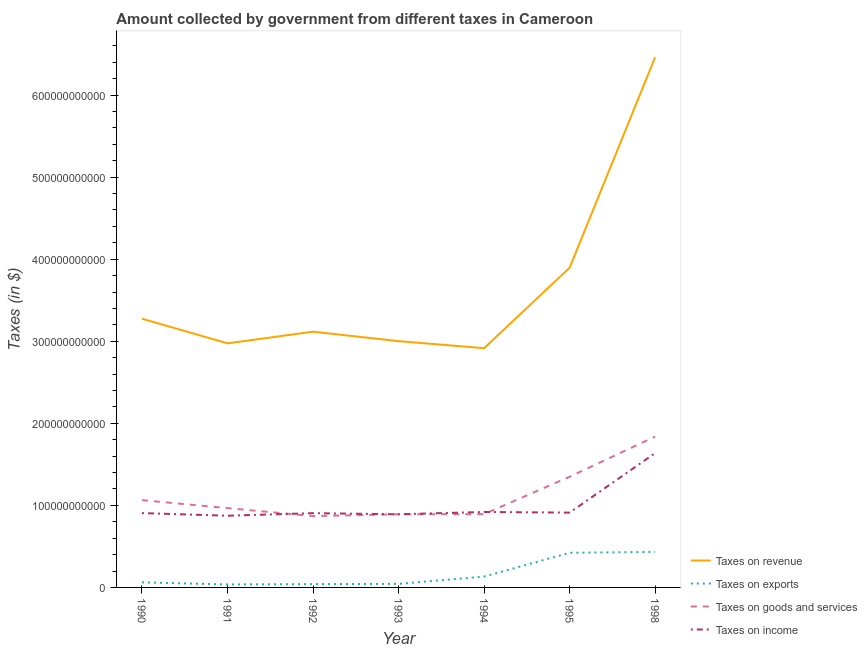How many different coloured lines are there?
Give a very brief answer. 4. Does the line corresponding to amount collected as tax on revenue intersect with the line corresponding to amount collected as tax on exports?
Keep it short and to the point. No. Is the number of lines equal to the number of legend labels?
Make the answer very short. Yes. What is the amount collected as tax on goods in 1990?
Give a very brief answer. 1.06e+11. Across all years, what is the maximum amount collected as tax on exports?
Your response must be concise. 4.33e+1. Across all years, what is the minimum amount collected as tax on revenue?
Keep it short and to the point. 2.92e+11. What is the total amount collected as tax on exports in the graph?
Make the answer very short. 1.17e+11. What is the difference between the amount collected as tax on revenue in 1991 and that in 1993?
Ensure brevity in your answer.  -2.68e+09. What is the difference between the amount collected as tax on revenue in 1993 and the amount collected as tax on exports in 1990?
Your response must be concise. 2.94e+11. What is the average amount collected as tax on revenue per year?
Give a very brief answer. 3.66e+11. In the year 1995, what is the difference between the amount collected as tax on exports and amount collected as tax on revenue?
Provide a short and direct response. -3.47e+11. In how many years, is the amount collected as tax on goods greater than 620000000000 $?
Your answer should be very brief. 0. What is the ratio of the amount collected as tax on income in 1993 to that in 1998?
Keep it short and to the point. 0.54. Is the amount collected as tax on exports in 1992 less than that in 1998?
Provide a succinct answer. Yes. What is the difference between the highest and the second highest amount collected as tax on goods?
Provide a short and direct response. 4.89e+1. What is the difference between the highest and the lowest amount collected as tax on goods?
Your response must be concise. 9.69e+1. In how many years, is the amount collected as tax on goods greater than the average amount collected as tax on goods taken over all years?
Your answer should be very brief. 2. How many lines are there?
Give a very brief answer. 4. What is the difference between two consecutive major ticks on the Y-axis?
Give a very brief answer. 1.00e+11. Are the values on the major ticks of Y-axis written in scientific E-notation?
Give a very brief answer. No. Does the graph contain any zero values?
Ensure brevity in your answer.  No. Where does the legend appear in the graph?
Provide a short and direct response. Bottom right. What is the title of the graph?
Your answer should be very brief. Amount collected by government from different taxes in Cameroon. What is the label or title of the X-axis?
Your answer should be compact. Year. What is the label or title of the Y-axis?
Make the answer very short. Taxes (in $). What is the Taxes (in $) of Taxes on revenue in 1990?
Give a very brief answer. 3.27e+11. What is the Taxes (in $) in Taxes on exports in 1990?
Ensure brevity in your answer.  6.18e+09. What is the Taxes (in $) in Taxes on goods and services in 1990?
Provide a succinct answer. 1.06e+11. What is the Taxes (in $) of Taxes on income in 1990?
Keep it short and to the point. 9.06e+1. What is the Taxes (in $) of Taxes on revenue in 1991?
Your answer should be very brief. 2.97e+11. What is the Taxes (in $) of Taxes on exports in 1991?
Keep it short and to the point. 3.64e+09. What is the Taxes (in $) in Taxes on goods and services in 1991?
Provide a succinct answer. 9.67e+1. What is the Taxes (in $) of Taxes on income in 1991?
Your answer should be compact. 8.74e+1. What is the Taxes (in $) in Taxes on revenue in 1992?
Make the answer very short. 3.12e+11. What is the Taxes (in $) in Taxes on exports in 1992?
Provide a succinct answer. 4.03e+09. What is the Taxes (in $) in Taxes on goods and services in 1992?
Give a very brief answer. 8.69e+1. What is the Taxes (in $) in Taxes on income in 1992?
Offer a very short reply. 9.05e+1. What is the Taxes (in $) of Taxes on revenue in 1993?
Provide a short and direct response. 3.00e+11. What is the Taxes (in $) of Taxes on exports in 1993?
Make the answer very short. 4.35e+09. What is the Taxes (in $) in Taxes on goods and services in 1993?
Your answer should be very brief. 8.92e+1. What is the Taxes (in $) in Taxes on income in 1993?
Make the answer very short. 8.92e+1. What is the Taxes (in $) of Taxes on revenue in 1994?
Give a very brief answer. 2.92e+11. What is the Taxes (in $) in Taxes on exports in 1994?
Keep it short and to the point. 1.32e+1. What is the Taxes (in $) in Taxes on goods and services in 1994?
Offer a very short reply. 8.93e+1. What is the Taxes (in $) in Taxes on income in 1994?
Give a very brief answer. 9.19e+1. What is the Taxes (in $) of Taxes on revenue in 1995?
Your answer should be compact. 3.90e+11. What is the Taxes (in $) of Taxes on exports in 1995?
Ensure brevity in your answer.  4.22e+1. What is the Taxes (in $) of Taxes on goods and services in 1995?
Offer a terse response. 1.35e+11. What is the Taxes (in $) of Taxes on income in 1995?
Your response must be concise. 9.12e+1. What is the Taxes (in $) in Taxes on revenue in 1998?
Provide a succinct answer. 6.46e+11. What is the Taxes (in $) of Taxes on exports in 1998?
Give a very brief answer. 4.33e+1. What is the Taxes (in $) of Taxes on goods and services in 1998?
Your answer should be compact. 1.84e+11. What is the Taxes (in $) of Taxes on income in 1998?
Provide a short and direct response. 1.64e+11. Across all years, what is the maximum Taxes (in $) in Taxes on revenue?
Give a very brief answer. 6.46e+11. Across all years, what is the maximum Taxes (in $) in Taxes on exports?
Your response must be concise. 4.33e+1. Across all years, what is the maximum Taxes (in $) of Taxes on goods and services?
Offer a very short reply. 1.84e+11. Across all years, what is the maximum Taxes (in $) of Taxes on income?
Your response must be concise. 1.64e+11. Across all years, what is the minimum Taxes (in $) of Taxes on revenue?
Your response must be concise. 2.92e+11. Across all years, what is the minimum Taxes (in $) in Taxes on exports?
Offer a very short reply. 3.64e+09. Across all years, what is the minimum Taxes (in $) of Taxes on goods and services?
Make the answer very short. 8.69e+1. Across all years, what is the minimum Taxes (in $) of Taxes on income?
Offer a very short reply. 8.74e+1. What is the total Taxes (in $) of Taxes on revenue in the graph?
Make the answer very short. 2.56e+12. What is the total Taxes (in $) in Taxes on exports in the graph?
Your answer should be very brief. 1.17e+11. What is the total Taxes (in $) in Taxes on goods and services in the graph?
Make the answer very short. 7.87e+11. What is the total Taxes (in $) in Taxes on income in the graph?
Offer a very short reply. 7.04e+11. What is the difference between the Taxes (in $) in Taxes on revenue in 1990 and that in 1991?
Your response must be concise. 3.00e+1. What is the difference between the Taxes (in $) of Taxes on exports in 1990 and that in 1991?
Your answer should be compact. 2.54e+09. What is the difference between the Taxes (in $) of Taxes on goods and services in 1990 and that in 1991?
Ensure brevity in your answer.  9.71e+09. What is the difference between the Taxes (in $) in Taxes on income in 1990 and that in 1991?
Your answer should be very brief. 3.21e+09. What is the difference between the Taxes (in $) of Taxes on revenue in 1990 and that in 1992?
Provide a short and direct response. 1.58e+1. What is the difference between the Taxes (in $) in Taxes on exports in 1990 and that in 1992?
Make the answer very short. 2.15e+09. What is the difference between the Taxes (in $) of Taxes on goods and services in 1990 and that in 1992?
Offer a terse response. 1.94e+1. What is the difference between the Taxes (in $) of Taxes on income in 1990 and that in 1992?
Give a very brief answer. 9.00e+07. What is the difference between the Taxes (in $) in Taxes on revenue in 1990 and that in 1993?
Provide a short and direct response. 2.74e+1. What is the difference between the Taxes (in $) in Taxes on exports in 1990 and that in 1993?
Keep it short and to the point. 1.83e+09. What is the difference between the Taxes (in $) in Taxes on goods and services in 1990 and that in 1993?
Provide a short and direct response. 1.72e+1. What is the difference between the Taxes (in $) of Taxes on income in 1990 and that in 1993?
Provide a succinct answer. 1.44e+09. What is the difference between the Taxes (in $) in Taxes on revenue in 1990 and that in 1994?
Make the answer very short. 3.59e+1. What is the difference between the Taxes (in $) in Taxes on exports in 1990 and that in 1994?
Provide a short and direct response. -7.05e+09. What is the difference between the Taxes (in $) in Taxes on goods and services in 1990 and that in 1994?
Keep it short and to the point. 1.71e+1. What is the difference between the Taxes (in $) of Taxes on income in 1990 and that in 1994?
Your response must be concise. -1.35e+09. What is the difference between the Taxes (in $) in Taxes on revenue in 1990 and that in 1995?
Ensure brevity in your answer.  -6.21e+1. What is the difference between the Taxes (in $) in Taxes on exports in 1990 and that in 1995?
Provide a succinct answer. -3.60e+1. What is the difference between the Taxes (in $) of Taxes on goods and services in 1990 and that in 1995?
Your answer should be compact. -2.85e+1. What is the difference between the Taxes (in $) in Taxes on income in 1990 and that in 1995?
Your answer should be compact. -5.60e+08. What is the difference between the Taxes (in $) in Taxes on revenue in 1990 and that in 1998?
Make the answer very short. -3.19e+11. What is the difference between the Taxes (in $) of Taxes on exports in 1990 and that in 1998?
Your answer should be very brief. -3.71e+1. What is the difference between the Taxes (in $) of Taxes on goods and services in 1990 and that in 1998?
Offer a very short reply. -7.74e+1. What is the difference between the Taxes (in $) in Taxes on income in 1990 and that in 1998?
Your answer should be very brief. -7.31e+1. What is the difference between the Taxes (in $) in Taxes on revenue in 1991 and that in 1992?
Your answer should be compact. -1.42e+1. What is the difference between the Taxes (in $) of Taxes on exports in 1991 and that in 1992?
Your answer should be compact. -3.90e+08. What is the difference between the Taxes (in $) of Taxes on goods and services in 1991 and that in 1992?
Your answer should be compact. 9.74e+09. What is the difference between the Taxes (in $) in Taxes on income in 1991 and that in 1992?
Offer a very short reply. -3.12e+09. What is the difference between the Taxes (in $) in Taxes on revenue in 1991 and that in 1993?
Give a very brief answer. -2.68e+09. What is the difference between the Taxes (in $) in Taxes on exports in 1991 and that in 1993?
Provide a succinct answer. -7.10e+08. What is the difference between the Taxes (in $) in Taxes on goods and services in 1991 and that in 1993?
Give a very brief answer. 7.50e+09. What is the difference between the Taxes (in $) of Taxes on income in 1991 and that in 1993?
Your answer should be very brief. -1.77e+09. What is the difference between the Taxes (in $) in Taxes on revenue in 1991 and that in 1994?
Offer a very short reply. 5.91e+09. What is the difference between the Taxes (in $) of Taxes on exports in 1991 and that in 1994?
Provide a short and direct response. -9.59e+09. What is the difference between the Taxes (in $) in Taxes on goods and services in 1991 and that in 1994?
Keep it short and to the point. 7.35e+09. What is the difference between the Taxes (in $) in Taxes on income in 1991 and that in 1994?
Ensure brevity in your answer.  -4.56e+09. What is the difference between the Taxes (in $) in Taxes on revenue in 1991 and that in 1995?
Your response must be concise. -9.21e+1. What is the difference between the Taxes (in $) in Taxes on exports in 1991 and that in 1995?
Your answer should be compact. -3.86e+1. What is the difference between the Taxes (in $) in Taxes on goods and services in 1991 and that in 1995?
Your answer should be very brief. -3.82e+1. What is the difference between the Taxes (in $) in Taxes on income in 1991 and that in 1995?
Keep it short and to the point. -3.77e+09. What is the difference between the Taxes (in $) of Taxes on revenue in 1991 and that in 1998?
Offer a very short reply. -3.49e+11. What is the difference between the Taxes (in $) in Taxes on exports in 1991 and that in 1998?
Offer a terse response. -3.97e+1. What is the difference between the Taxes (in $) of Taxes on goods and services in 1991 and that in 1998?
Provide a succinct answer. -8.72e+1. What is the difference between the Taxes (in $) in Taxes on income in 1991 and that in 1998?
Offer a terse response. -7.63e+1. What is the difference between the Taxes (in $) in Taxes on revenue in 1992 and that in 1993?
Provide a succinct answer. 1.15e+1. What is the difference between the Taxes (in $) of Taxes on exports in 1992 and that in 1993?
Give a very brief answer. -3.20e+08. What is the difference between the Taxes (in $) of Taxes on goods and services in 1992 and that in 1993?
Give a very brief answer. -2.24e+09. What is the difference between the Taxes (in $) in Taxes on income in 1992 and that in 1993?
Keep it short and to the point. 1.35e+09. What is the difference between the Taxes (in $) of Taxes on revenue in 1992 and that in 1994?
Your answer should be very brief. 2.01e+1. What is the difference between the Taxes (in $) in Taxes on exports in 1992 and that in 1994?
Offer a terse response. -9.20e+09. What is the difference between the Taxes (in $) of Taxes on goods and services in 1992 and that in 1994?
Make the answer very short. -2.39e+09. What is the difference between the Taxes (in $) of Taxes on income in 1992 and that in 1994?
Provide a short and direct response. -1.44e+09. What is the difference between the Taxes (in $) of Taxes on revenue in 1992 and that in 1995?
Your answer should be compact. -7.79e+1. What is the difference between the Taxes (in $) in Taxes on exports in 1992 and that in 1995?
Your answer should be very brief. -3.82e+1. What is the difference between the Taxes (in $) of Taxes on goods and services in 1992 and that in 1995?
Keep it short and to the point. -4.80e+1. What is the difference between the Taxes (in $) of Taxes on income in 1992 and that in 1995?
Provide a short and direct response. -6.50e+08. What is the difference between the Taxes (in $) of Taxes on revenue in 1992 and that in 1998?
Provide a succinct answer. -3.35e+11. What is the difference between the Taxes (in $) of Taxes on exports in 1992 and that in 1998?
Keep it short and to the point. -3.93e+1. What is the difference between the Taxes (in $) in Taxes on goods and services in 1992 and that in 1998?
Your answer should be compact. -9.69e+1. What is the difference between the Taxes (in $) of Taxes on income in 1992 and that in 1998?
Keep it short and to the point. -7.32e+1. What is the difference between the Taxes (in $) of Taxes on revenue in 1993 and that in 1994?
Your answer should be very brief. 8.59e+09. What is the difference between the Taxes (in $) of Taxes on exports in 1993 and that in 1994?
Offer a very short reply. -8.88e+09. What is the difference between the Taxes (in $) in Taxes on goods and services in 1993 and that in 1994?
Provide a short and direct response. -1.50e+08. What is the difference between the Taxes (in $) of Taxes on income in 1993 and that in 1994?
Make the answer very short. -2.79e+09. What is the difference between the Taxes (in $) of Taxes on revenue in 1993 and that in 1995?
Provide a succinct answer. -8.94e+1. What is the difference between the Taxes (in $) in Taxes on exports in 1993 and that in 1995?
Your answer should be compact. -3.79e+1. What is the difference between the Taxes (in $) in Taxes on goods and services in 1993 and that in 1995?
Provide a short and direct response. -4.57e+1. What is the difference between the Taxes (in $) in Taxes on income in 1993 and that in 1995?
Offer a terse response. -2.00e+09. What is the difference between the Taxes (in $) in Taxes on revenue in 1993 and that in 1998?
Give a very brief answer. -3.46e+11. What is the difference between the Taxes (in $) of Taxes on exports in 1993 and that in 1998?
Offer a very short reply. -3.90e+1. What is the difference between the Taxes (in $) of Taxes on goods and services in 1993 and that in 1998?
Give a very brief answer. -9.47e+1. What is the difference between the Taxes (in $) of Taxes on income in 1993 and that in 1998?
Provide a succinct answer. -7.45e+1. What is the difference between the Taxes (in $) in Taxes on revenue in 1994 and that in 1995?
Give a very brief answer. -9.80e+1. What is the difference between the Taxes (in $) in Taxes on exports in 1994 and that in 1995?
Your answer should be compact. -2.90e+1. What is the difference between the Taxes (in $) of Taxes on goods and services in 1994 and that in 1995?
Your answer should be very brief. -4.56e+1. What is the difference between the Taxes (in $) of Taxes on income in 1994 and that in 1995?
Offer a terse response. 7.90e+08. What is the difference between the Taxes (in $) in Taxes on revenue in 1994 and that in 1998?
Offer a very short reply. -3.55e+11. What is the difference between the Taxes (in $) in Taxes on exports in 1994 and that in 1998?
Provide a short and direct response. -3.01e+1. What is the difference between the Taxes (in $) in Taxes on goods and services in 1994 and that in 1998?
Provide a short and direct response. -9.45e+1. What is the difference between the Taxes (in $) of Taxes on income in 1994 and that in 1998?
Keep it short and to the point. -7.18e+1. What is the difference between the Taxes (in $) in Taxes on revenue in 1995 and that in 1998?
Your response must be concise. -2.57e+11. What is the difference between the Taxes (in $) in Taxes on exports in 1995 and that in 1998?
Offer a very short reply. -1.11e+09. What is the difference between the Taxes (in $) in Taxes on goods and services in 1995 and that in 1998?
Offer a very short reply. -4.89e+1. What is the difference between the Taxes (in $) of Taxes on income in 1995 and that in 1998?
Your response must be concise. -7.25e+1. What is the difference between the Taxes (in $) of Taxes on revenue in 1990 and the Taxes (in $) of Taxes on exports in 1991?
Ensure brevity in your answer.  3.24e+11. What is the difference between the Taxes (in $) in Taxes on revenue in 1990 and the Taxes (in $) in Taxes on goods and services in 1991?
Keep it short and to the point. 2.31e+11. What is the difference between the Taxes (in $) in Taxes on revenue in 1990 and the Taxes (in $) in Taxes on income in 1991?
Offer a terse response. 2.40e+11. What is the difference between the Taxes (in $) in Taxes on exports in 1990 and the Taxes (in $) in Taxes on goods and services in 1991?
Keep it short and to the point. -9.05e+1. What is the difference between the Taxes (in $) of Taxes on exports in 1990 and the Taxes (in $) of Taxes on income in 1991?
Your answer should be compact. -8.12e+1. What is the difference between the Taxes (in $) in Taxes on goods and services in 1990 and the Taxes (in $) in Taxes on income in 1991?
Make the answer very short. 1.90e+1. What is the difference between the Taxes (in $) of Taxes on revenue in 1990 and the Taxes (in $) of Taxes on exports in 1992?
Offer a terse response. 3.23e+11. What is the difference between the Taxes (in $) of Taxes on revenue in 1990 and the Taxes (in $) of Taxes on goods and services in 1992?
Offer a terse response. 2.41e+11. What is the difference between the Taxes (in $) of Taxes on revenue in 1990 and the Taxes (in $) of Taxes on income in 1992?
Provide a succinct answer. 2.37e+11. What is the difference between the Taxes (in $) of Taxes on exports in 1990 and the Taxes (in $) of Taxes on goods and services in 1992?
Provide a succinct answer. -8.07e+1. What is the difference between the Taxes (in $) in Taxes on exports in 1990 and the Taxes (in $) in Taxes on income in 1992?
Offer a very short reply. -8.43e+1. What is the difference between the Taxes (in $) in Taxes on goods and services in 1990 and the Taxes (in $) in Taxes on income in 1992?
Your response must be concise. 1.59e+1. What is the difference between the Taxes (in $) of Taxes on revenue in 1990 and the Taxes (in $) of Taxes on exports in 1993?
Your answer should be compact. 3.23e+11. What is the difference between the Taxes (in $) in Taxes on revenue in 1990 and the Taxes (in $) in Taxes on goods and services in 1993?
Provide a succinct answer. 2.38e+11. What is the difference between the Taxes (in $) in Taxes on revenue in 1990 and the Taxes (in $) in Taxes on income in 1993?
Ensure brevity in your answer.  2.38e+11. What is the difference between the Taxes (in $) in Taxes on exports in 1990 and the Taxes (in $) in Taxes on goods and services in 1993?
Ensure brevity in your answer.  -8.30e+1. What is the difference between the Taxes (in $) of Taxes on exports in 1990 and the Taxes (in $) of Taxes on income in 1993?
Offer a terse response. -8.30e+1. What is the difference between the Taxes (in $) of Taxes on goods and services in 1990 and the Taxes (in $) of Taxes on income in 1993?
Your answer should be compact. 1.72e+1. What is the difference between the Taxes (in $) of Taxes on revenue in 1990 and the Taxes (in $) of Taxes on exports in 1994?
Provide a succinct answer. 3.14e+11. What is the difference between the Taxes (in $) in Taxes on revenue in 1990 and the Taxes (in $) in Taxes on goods and services in 1994?
Make the answer very short. 2.38e+11. What is the difference between the Taxes (in $) in Taxes on revenue in 1990 and the Taxes (in $) in Taxes on income in 1994?
Provide a short and direct response. 2.36e+11. What is the difference between the Taxes (in $) in Taxes on exports in 1990 and the Taxes (in $) in Taxes on goods and services in 1994?
Offer a terse response. -8.31e+1. What is the difference between the Taxes (in $) of Taxes on exports in 1990 and the Taxes (in $) of Taxes on income in 1994?
Provide a succinct answer. -8.58e+1. What is the difference between the Taxes (in $) in Taxes on goods and services in 1990 and the Taxes (in $) in Taxes on income in 1994?
Ensure brevity in your answer.  1.44e+1. What is the difference between the Taxes (in $) of Taxes on revenue in 1990 and the Taxes (in $) of Taxes on exports in 1995?
Keep it short and to the point. 2.85e+11. What is the difference between the Taxes (in $) in Taxes on revenue in 1990 and the Taxes (in $) in Taxes on goods and services in 1995?
Your answer should be compact. 1.93e+11. What is the difference between the Taxes (in $) in Taxes on revenue in 1990 and the Taxes (in $) in Taxes on income in 1995?
Your answer should be compact. 2.36e+11. What is the difference between the Taxes (in $) of Taxes on exports in 1990 and the Taxes (in $) of Taxes on goods and services in 1995?
Your response must be concise. -1.29e+11. What is the difference between the Taxes (in $) of Taxes on exports in 1990 and the Taxes (in $) of Taxes on income in 1995?
Offer a very short reply. -8.50e+1. What is the difference between the Taxes (in $) in Taxes on goods and services in 1990 and the Taxes (in $) in Taxes on income in 1995?
Your answer should be compact. 1.52e+1. What is the difference between the Taxes (in $) of Taxes on revenue in 1990 and the Taxes (in $) of Taxes on exports in 1998?
Ensure brevity in your answer.  2.84e+11. What is the difference between the Taxes (in $) in Taxes on revenue in 1990 and the Taxes (in $) in Taxes on goods and services in 1998?
Your answer should be compact. 1.44e+11. What is the difference between the Taxes (in $) of Taxes on revenue in 1990 and the Taxes (in $) of Taxes on income in 1998?
Provide a succinct answer. 1.64e+11. What is the difference between the Taxes (in $) of Taxes on exports in 1990 and the Taxes (in $) of Taxes on goods and services in 1998?
Your answer should be compact. -1.78e+11. What is the difference between the Taxes (in $) in Taxes on exports in 1990 and the Taxes (in $) in Taxes on income in 1998?
Offer a terse response. -1.58e+11. What is the difference between the Taxes (in $) of Taxes on goods and services in 1990 and the Taxes (in $) of Taxes on income in 1998?
Ensure brevity in your answer.  -5.73e+1. What is the difference between the Taxes (in $) in Taxes on revenue in 1991 and the Taxes (in $) in Taxes on exports in 1992?
Provide a short and direct response. 2.93e+11. What is the difference between the Taxes (in $) in Taxes on revenue in 1991 and the Taxes (in $) in Taxes on goods and services in 1992?
Your response must be concise. 2.11e+11. What is the difference between the Taxes (in $) in Taxes on revenue in 1991 and the Taxes (in $) in Taxes on income in 1992?
Your response must be concise. 2.07e+11. What is the difference between the Taxes (in $) of Taxes on exports in 1991 and the Taxes (in $) of Taxes on goods and services in 1992?
Your answer should be compact. -8.33e+1. What is the difference between the Taxes (in $) of Taxes on exports in 1991 and the Taxes (in $) of Taxes on income in 1992?
Your answer should be very brief. -8.69e+1. What is the difference between the Taxes (in $) of Taxes on goods and services in 1991 and the Taxes (in $) of Taxes on income in 1992?
Your response must be concise. 6.16e+09. What is the difference between the Taxes (in $) in Taxes on revenue in 1991 and the Taxes (in $) in Taxes on exports in 1993?
Your answer should be very brief. 2.93e+11. What is the difference between the Taxes (in $) of Taxes on revenue in 1991 and the Taxes (in $) of Taxes on goods and services in 1993?
Offer a very short reply. 2.08e+11. What is the difference between the Taxes (in $) in Taxes on revenue in 1991 and the Taxes (in $) in Taxes on income in 1993?
Ensure brevity in your answer.  2.08e+11. What is the difference between the Taxes (in $) of Taxes on exports in 1991 and the Taxes (in $) of Taxes on goods and services in 1993?
Keep it short and to the point. -8.55e+1. What is the difference between the Taxes (in $) of Taxes on exports in 1991 and the Taxes (in $) of Taxes on income in 1993?
Your answer should be compact. -8.55e+1. What is the difference between the Taxes (in $) in Taxes on goods and services in 1991 and the Taxes (in $) in Taxes on income in 1993?
Keep it short and to the point. 7.51e+09. What is the difference between the Taxes (in $) of Taxes on revenue in 1991 and the Taxes (in $) of Taxes on exports in 1994?
Your answer should be compact. 2.84e+11. What is the difference between the Taxes (in $) in Taxes on revenue in 1991 and the Taxes (in $) in Taxes on goods and services in 1994?
Provide a succinct answer. 2.08e+11. What is the difference between the Taxes (in $) in Taxes on revenue in 1991 and the Taxes (in $) in Taxes on income in 1994?
Your answer should be very brief. 2.06e+11. What is the difference between the Taxes (in $) in Taxes on exports in 1991 and the Taxes (in $) in Taxes on goods and services in 1994?
Your answer should be very brief. -8.57e+1. What is the difference between the Taxes (in $) of Taxes on exports in 1991 and the Taxes (in $) of Taxes on income in 1994?
Provide a short and direct response. -8.83e+1. What is the difference between the Taxes (in $) in Taxes on goods and services in 1991 and the Taxes (in $) in Taxes on income in 1994?
Your answer should be very brief. 4.72e+09. What is the difference between the Taxes (in $) in Taxes on revenue in 1991 and the Taxes (in $) in Taxes on exports in 1995?
Keep it short and to the point. 2.55e+11. What is the difference between the Taxes (in $) of Taxes on revenue in 1991 and the Taxes (in $) of Taxes on goods and services in 1995?
Offer a terse response. 1.63e+11. What is the difference between the Taxes (in $) in Taxes on revenue in 1991 and the Taxes (in $) in Taxes on income in 1995?
Provide a succinct answer. 2.06e+11. What is the difference between the Taxes (in $) in Taxes on exports in 1991 and the Taxes (in $) in Taxes on goods and services in 1995?
Make the answer very short. -1.31e+11. What is the difference between the Taxes (in $) of Taxes on exports in 1991 and the Taxes (in $) of Taxes on income in 1995?
Keep it short and to the point. -8.75e+1. What is the difference between the Taxes (in $) in Taxes on goods and services in 1991 and the Taxes (in $) in Taxes on income in 1995?
Your answer should be compact. 5.51e+09. What is the difference between the Taxes (in $) of Taxes on revenue in 1991 and the Taxes (in $) of Taxes on exports in 1998?
Your answer should be compact. 2.54e+11. What is the difference between the Taxes (in $) in Taxes on revenue in 1991 and the Taxes (in $) in Taxes on goods and services in 1998?
Offer a terse response. 1.14e+11. What is the difference between the Taxes (in $) in Taxes on revenue in 1991 and the Taxes (in $) in Taxes on income in 1998?
Offer a terse response. 1.34e+11. What is the difference between the Taxes (in $) in Taxes on exports in 1991 and the Taxes (in $) in Taxes on goods and services in 1998?
Ensure brevity in your answer.  -1.80e+11. What is the difference between the Taxes (in $) of Taxes on exports in 1991 and the Taxes (in $) of Taxes on income in 1998?
Your response must be concise. -1.60e+11. What is the difference between the Taxes (in $) of Taxes on goods and services in 1991 and the Taxes (in $) of Taxes on income in 1998?
Your answer should be compact. -6.70e+1. What is the difference between the Taxes (in $) in Taxes on revenue in 1992 and the Taxes (in $) in Taxes on exports in 1993?
Keep it short and to the point. 3.07e+11. What is the difference between the Taxes (in $) of Taxes on revenue in 1992 and the Taxes (in $) of Taxes on goods and services in 1993?
Make the answer very short. 2.22e+11. What is the difference between the Taxes (in $) of Taxes on revenue in 1992 and the Taxes (in $) of Taxes on income in 1993?
Keep it short and to the point. 2.23e+11. What is the difference between the Taxes (in $) in Taxes on exports in 1992 and the Taxes (in $) in Taxes on goods and services in 1993?
Ensure brevity in your answer.  -8.51e+1. What is the difference between the Taxes (in $) of Taxes on exports in 1992 and the Taxes (in $) of Taxes on income in 1993?
Make the answer very short. -8.51e+1. What is the difference between the Taxes (in $) in Taxes on goods and services in 1992 and the Taxes (in $) in Taxes on income in 1993?
Offer a very short reply. -2.23e+09. What is the difference between the Taxes (in $) of Taxes on revenue in 1992 and the Taxes (in $) of Taxes on exports in 1994?
Provide a short and direct response. 2.98e+11. What is the difference between the Taxes (in $) of Taxes on revenue in 1992 and the Taxes (in $) of Taxes on goods and services in 1994?
Make the answer very short. 2.22e+11. What is the difference between the Taxes (in $) in Taxes on revenue in 1992 and the Taxes (in $) in Taxes on income in 1994?
Offer a terse response. 2.20e+11. What is the difference between the Taxes (in $) of Taxes on exports in 1992 and the Taxes (in $) of Taxes on goods and services in 1994?
Your answer should be very brief. -8.53e+1. What is the difference between the Taxes (in $) in Taxes on exports in 1992 and the Taxes (in $) in Taxes on income in 1994?
Offer a very short reply. -8.79e+1. What is the difference between the Taxes (in $) of Taxes on goods and services in 1992 and the Taxes (in $) of Taxes on income in 1994?
Offer a very short reply. -5.02e+09. What is the difference between the Taxes (in $) in Taxes on revenue in 1992 and the Taxes (in $) in Taxes on exports in 1995?
Make the answer very short. 2.69e+11. What is the difference between the Taxes (in $) in Taxes on revenue in 1992 and the Taxes (in $) in Taxes on goods and services in 1995?
Your response must be concise. 1.77e+11. What is the difference between the Taxes (in $) in Taxes on revenue in 1992 and the Taxes (in $) in Taxes on income in 1995?
Keep it short and to the point. 2.21e+11. What is the difference between the Taxes (in $) of Taxes on exports in 1992 and the Taxes (in $) of Taxes on goods and services in 1995?
Offer a very short reply. -1.31e+11. What is the difference between the Taxes (in $) in Taxes on exports in 1992 and the Taxes (in $) in Taxes on income in 1995?
Offer a terse response. -8.71e+1. What is the difference between the Taxes (in $) in Taxes on goods and services in 1992 and the Taxes (in $) in Taxes on income in 1995?
Give a very brief answer. -4.23e+09. What is the difference between the Taxes (in $) in Taxes on revenue in 1992 and the Taxes (in $) in Taxes on exports in 1998?
Your response must be concise. 2.68e+11. What is the difference between the Taxes (in $) in Taxes on revenue in 1992 and the Taxes (in $) in Taxes on goods and services in 1998?
Offer a very short reply. 1.28e+11. What is the difference between the Taxes (in $) in Taxes on revenue in 1992 and the Taxes (in $) in Taxes on income in 1998?
Offer a very short reply. 1.48e+11. What is the difference between the Taxes (in $) of Taxes on exports in 1992 and the Taxes (in $) of Taxes on goods and services in 1998?
Your answer should be compact. -1.80e+11. What is the difference between the Taxes (in $) in Taxes on exports in 1992 and the Taxes (in $) in Taxes on income in 1998?
Offer a terse response. -1.60e+11. What is the difference between the Taxes (in $) of Taxes on goods and services in 1992 and the Taxes (in $) of Taxes on income in 1998?
Ensure brevity in your answer.  -7.68e+1. What is the difference between the Taxes (in $) in Taxes on revenue in 1993 and the Taxes (in $) in Taxes on exports in 1994?
Provide a short and direct response. 2.87e+11. What is the difference between the Taxes (in $) in Taxes on revenue in 1993 and the Taxes (in $) in Taxes on goods and services in 1994?
Offer a very short reply. 2.11e+11. What is the difference between the Taxes (in $) in Taxes on revenue in 1993 and the Taxes (in $) in Taxes on income in 1994?
Your response must be concise. 2.08e+11. What is the difference between the Taxes (in $) of Taxes on exports in 1993 and the Taxes (in $) of Taxes on goods and services in 1994?
Your response must be concise. -8.50e+1. What is the difference between the Taxes (in $) in Taxes on exports in 1993 and the Taxes (in $) in Taxes on income in 1994?
Your response must be concise. -8.76e+1. What is the difference between the Taxes (in $) of Taxes on goods and services in 1993 and the Taxes (in $) of Taxes on income in 1994?
Provide a succinct answer. -2.78e+09. What is the difference between the Taxes (in $) in Taxes on revenue in 1993 and the Taxes (in $) in Taxes on exports in 1995?
Give a very brief answer. 2.58e+11. What is the difference between the Taxes (in $) of Taxes on revenue in 1993 and the Taxes (in $) of Taxes on goods and services in 1995?
Keep it short and to the point. 1.65e+11. What is the difference between the Taxes (in $) of Taxes on revenue in 1993 and the Taxes (in $) of Taxes on income in 1995?
Offer a very short reply. 2.09e+11. What is the difference between the Taxes (in $) in Taxes on exports in 1993 and the Taxes (in $) in Taxes on goods and services in 1995?
Your answer should be very brief. -1.31e+11. What is the difference between the Taxes (in $) of Taxes on exports in 1993 and the Taxes (in $) of Taxes on income in 1995?
Give a very brief answer. -8.68e+1. What is the difference between the Taxes (in $) in Taxes on goods and services in 1993 and the Taxes (in $) in Taxes on income in 1995?
Give a very brief answer. -1.99e+09. What is the difference between the Taxes (in $) in Taxes on revenue in 1993 and the Taxes (in $) in Taxes on exports in 1998?
Make the answer very short. 2.57e+11. What is the difference between the Taxes (in $) in Taxes on revenue in 1993 and the Taxes (in $) in Taxes on goods and services in 1998?
Offer a very short reply. 1.16e+11. What is the difference between the Taxes (in $) of Taxes on revenue in 1993 and the Taxes (in $) of Taxes on income in 1998?
Make the answer very short. 1.36e+11. What is the difference between the Taxes (in $) in Taxes on exports in 1993 and the Taxes (in $) in Taxes on goods and services in 1998?
Provide a succinct answer. -1.79e+11. What is the difference between the Taxes (in $) in Taxes on exports in 1993 and the Taxes (in $) in Taxes on income in 1998?
Your answer should be compact. -1.59e+11. What is the difference between the Taxes (in $) in Taxes on goods and services in 1993 and the Taxes (in $) in Taxes on income in 1998?
Make the answer very short. -7.45e+1. What is the difference between the Taxes (in $) in Taxes on revenue in 1994 and the Taxes (in $) in Taxes on exports in 1995?
Your response must be concise. 2.49e+11. What is the difference between the Taxes (in $) in Taxes on revenue in 1994 and the Taxes (in $) in Taxes on goods and services in 1995?
Your answer should be compact. 1.57e+11. What is the difference between the Taxes (in $) in Taxes on revenue in 1994 and the Taxes (in $) in Taxes on income in 1995?
Your answer should be very brief. 2.00e+11. What is the difference between the Taxes (in $) of Taxes on exports in 1994 and the Taxes (in $) of Taxes on goods and services in 1995?
Offer a terse response. -1.22e+11. What is the difference between the Taxes (in $) of Taxes on exports in 1994 and the Taxes (in $) of Taxes on income in 1995?
Provide a short and direct response. -7.79e+1. What is the difference between the Taxes (in $) in Taxes on goods and services in 1994 and the Taxes (in $) in Taxes on income in 1995?
Provide a succinct answer. -1.84e+09. What is the difference between the Taxes (in $) of Taxes on revenue in 1994 and the Taxes (in $) of Taxes on exports in 1998?
Keep it short and to the point. 2.48e+11. What is the difference between the Taxes (in $) of Taxes on revenue in 1994 and the Taxes (in $) of Taxes on goods and services in 1998?
Provide a short and direct response. 1.08e+11. What is the difference between the Taxes (in $) in Taxes on revenue in 1994 and the Taxes (in $) in Taxes on income in 1998?
Offer a terse response. 1.28e+11. What is the difference between the Taxes (in $) of Taxes on exports in 1994 and the Taxes (in $) of Taxes on goods and services in 1998?
Give a very brief answer. -1.71e+11. What is the difference between the Taxes (in $) of Taxes on exports in 1994 and the Taxes (in $) of Taxes on income in 1998?
Your answer should be very brief. -1.50e+11. What is the difference between the Taxes (in $) of Taxes on goods and services in 1994 and the Taxes (in $) of Taxes on income in 1998?
Provide a succinct answer. -7.44e+1. What is the difference between the Taxes (in $) of Taxes on revenue in 1995 and the Taxes (in $) of Taxes on exports in 1998?
Give a very brief answer. 3.46e+11. What is the difference between the Taxes (in $) in Taxes on revenue in 1995 and the Taxes (in $) in Taxes on goods and services in 1998?
Offer a terse response. 2.06e+11. What is the difference between the Taxes (in $) of Taxes on revenue in 1995 and the Taxes (in $) of Taxes on income in 1998?
Provide a succinct answer. 2.26e+11. What is the difference between the Taxes (in $) of Taxes on exports in 1995 and the Taxes (in $) of Taxes on goods and services in 1998?
Keep it short and to the point. -1.42e+11. What is the difference between the Taxes (in $) of Taxes on exports in 1995 and the Taxes (in $) of Taxes on income in 1998?
Keep it short and to the point. -1.21e+11. What is the difference between the Taxes (in $) in Taxes on goods and services in 1995 and the Taxes (in $) in Taxes on income in 1998?
Your answer should be very brief. -2.88e+1. What is the average Taxes (in $) of Taxes on revenue per year?
Keep it short and to the point. 3.66e+11. What is the average Taxes (in $) of Taxes on exports per year?
Ensure brevity in your answer.  1.67e+1. What is the average Taxes (in $) in Taxes on goods and services per year?
Offer a very short reply. 1.12e+11. What is the average Taxes (in $) of Taxes on income per year?
Your response must be concise. 1.01e+11. In the year 1990, what is the difference between the Taxes (in $) in Taxes on revenue and Taxes (in $) in Taxes on exports?
Provide a short and direct response. 3.21e+11. In the year 1990, what is the difference between the Taxes (in $) in Taxes on revenue and Taxes (in $) in Taxes on goods and services?
Provide a succinct answer. 2.21e+11. In the year 1990, what is the difference between the Taxes (in $) of Taxes on revenue and Taxes (in $) of Taxes on income?
Your response must be concise. 2.37e+11. In the year 1990, what is the difference between the Taxes (in $) of Taxes on exports and Taxes (in $) of Taxes on goods and services?
Your answer should be very brief. -1.00e+11. In the year 1990, what is the difference between the Taxes (in $) of Taxes on exports and Taxes (in $) of Taxes on income?
Provide a succinct answer. -8.44e+1. In the year 1990, what is the difference between the Taxes (in $) of Taxes on goods and services and Taxes (in $) of Taxes on income?
Provide a succinct answer. 1.58e+1. In the year 1991, what is the difference between the Taxes (in $) in Taxes on revenue and Taxes (in $) in Taxes on exports?
Your answer should be compact. 2.94e+11. In the year 1991, what is the difference between the Taxes (in $) in Taxes on revenue and Taxes (in $) in Taxes on goods and services?
Provide a succinct answer. 2.01e+11. In the year 1991, what is the difference between the Taxes (in $) in Taxes on revenue and Taxes (in $) in Taxes on income?
Keep it short and to the point. 2.10e+11. In the year 1991, what is the difference between the Taxes (in $) of Taxes on exports and Taxes (in $) of Taxes on goods and services?
Make the answer very short. -9.30e+1. In the year 1991, what is the difference between the Taxes (in $) in Taxes on exports and Taxes (in $) in Taxes on income?
Make the answer very short. -8.37e+1. In the year 1991, what is the difference between the Taxes (in $) in Taxes on goods and services and Taxes (in $) in Taxes on income?
Your answer should be compact. 9.28e+09. In the year 1992, what is the difference between the Taxes (in $) in Taxes on revenue and Taxes (in $) in Taxes on exports?
Keep it short and to the point. 3.08e+11. In the year 1992, what is the difference between the Taxes (in $) of Taxes on revenue and Taxes (in $) of Taxes on goods and services?
Offer a very short reply. 2.25e+11. In the year 1992, what is the difference between the Taxes (in $) in Taxes on revenue and Taxes (in $) in Taxes on income?
Provide a short and direct response. 2.21e+11. In the year 1992, what is the difference between the Taxes (in $) in Taxes on exports and Taxes (in $) in Taxes on goods and services?
Your answer should be very brief. -8.29e+1. In the year 1992, what is the difference between the Taxes (in $) in Taxes on exports and Taxes (in $) in Taxes on income?
Provide a short and direct response. -8.65e+1. In the year 1992, what is the difference between the Taxes (in $) in Taxes on goods and services and Taxes (in $) in Taxes on income?
Give a very brief answer. -3.58e+09. In the year 1993, what is the difference between the Taxes (in $) in Taxes on revenue and Taxes (in $) in Taxes on exports?
Ensure brevity in your answer.  2.96e+11. In the year 1993, what is the difference between the Taxes (in $) of Taxes on revenue and Taxes (in $) of Taxes on goods and services?
Make the answer very short. 2.11e+11. In the year 1993, what is the difference between the Taxes (in $) of Taxes on revenue and Taxes (in $) of Taxes on income?
Provide a succinct answer. 2.11e+11. In the year 1993, what is the difference between the Taxes (in $) of Taxes on exports and Taxes (in $) of Taxes on goods and services?
Your response must be concise. -8.48e+1. In the year 1993, what is the difference between the Taxes (in $) of Taxes on exports and Taxes (in $) of Taxes on income?
Your answer should be very brief. -8.48e+1. In the year 1994, what is the difference between the Taxes (in $) in Taxes on revenue and Taxes (in $) in Taxes on exports?
Ensure brevity in your answer.  2.78e+11. In the year 1994, what is the difference between the Taxes (in $) in Taxes on revenue and Taxes (in $) in Taxes on goods and services?
Make the answer very short. 2.02e+11. In the year 1994, what is the difference between the Taxes (in $) of Taxes on revenue and Taxes (in $) of Taxes on income?
Keep it short and to the point. 2.00e+11. In the year 1994, what is the difference between the Taxes (in $) of Taxes on exports and Taxes (in $) of Taxes on goods and services?
Make the answer very short. -7.61e+1. In the year 1994, what is the difference between the Taxes (in $) of Taxes on exports and Taxes (in $) of Taxes on income?
Provide a short and direct response. -7.87e+1. In the year 1994, what is the difference between the Taxes (in $) in Taxes on goods and services and Taxes (in $) in Taxes on income?
Your response must be concise. -2.63e+09. In the year 1995, what is the difference between the Taxes (in $) in Taxes on revenue and Taxes (in $) in Taxes on exports?
Your answer should be compact. 3.47e+11. In the year 1995, what is the difference between the Taxes (in $) of Taxes on revenue and Taxes (in $) of Taxes on goods and services?
Keep it short and to the point. 2.55e+11. In the year 1995, what is the difference between the Taxes (in $) of Taxes on revenue and Taxes (in $) of Taxes on income?
Your response must be concise. 2.98e+11. In the year 1995, what is the difference between the Taxes (in $) of Taxes on exports and Taxes (in $) of Taxes on goods and services?
Make the answer very short. -9.27e+1. In the year 1995, what is the difference between the Taxes (in $) in Taxes on exports and Taxes (in $) in Taxes on income?
Ensure brevity in your answer.  -4.89e+1. In the year 1995, what is the difference between the Taxes (in $) of Taxes on goods and services and Taxes (in $) of Taxes on income?
Your response must be concise. 4.37e+1. In the year 1998, what is the difference between the Taxes (in $) in Taxes on revenue and Taxes (in $) in Taxes on exports?
Your answer should be compact. 6.03e+11. In the year 1998, what is the difference between the Taxes (in $) in Taxes on revenue and Taxes (in $) in Taxes on goods and services?
Your response must be concise. 4.62e+11. In the year 1998, what is the difference between the Taxes (in $) of Taxes on revenue and Taxes (in $) of Taxes on income?
Offer a very short reply. 4.82e+11. In the year 1998, what is the difference between the Taxes (in $) of Taxes on exports and Taxes (in $) of Taxes on goods and services?
Give a very brief answer. -1.40e+11. In the year 1998, what is the difference between the Taxes (in $) in Taxes on exports and Taxes (in $) in Taxes on income?
Offer a terse response. -1.20e+11. In the year 1998, what is the difference between the Taxes (in $) in Taxes on goods and services and Taxes (in $) in Taxes on income?
Provide a short and direct response. 2.01e+1. What is the ratio of the Taxes (in $) of Taxes on revenue in 1990 to that in 1991?
Ensure brevity in your answer.  1.1. What is the ratio of the Taxes (in $) of Taxes on exports in 1990 to that in 1991?
Your answer should be compact. 1.7. What is the ratio of the Taxes (in $) in Taxes on goods and services in 1990 to that in 1991?
Your response must be concise. 1.1. What is the ratio of the Taxes (in $) in Taxes on income in 1990 to that in 1991?
Offer a very short reply. 1.04. What is the ratio of the Taxes (in $) of Taxes on revenue in 1990 to that in 1992?
Keep it short and to the point. 1.05. What is the ratio of the Taxes (in $) in Taxes on exports in 1990 to that in 1992?
Make the answer very short. 1.53. What is the ratio of the Taxes (in $) of Taxes on goods and services in 1990 to that in 1992?
Keep it short and to the point. 1.22. What is the ratio of the Taxes (in $) of Taxes on revenue in 1990 to that in 1993?
Provide a short and direct response. 1.09. What is the ratio of the Taxes (in $) of Taxes on exports in 1990 to that in 1993?
Make the answer very short. 1.42. What is the ratio of the Taxes (in $) in Taxes on goods and services in 1990 to that in 1993?
Your answer should be very brief. 1.19. What is the ratio of the Taxes (in $) of Taxes on income in 1990 to that in 1993?
Your response must be concise. 1.02. What is the ratio of the Taxes (in $) of Taxes on revenue in 1990 to that in 1994?
Offer a terse response. 1.12. What is the ratio of the Taxes (in $) of Taxes on exports in 1990 to that in 1994?
Offer a terse response. 0.47. What is the ratio of the Taxes (in $) of Taxes on goods and services in 1990 to that in 1994?
Provide a succinct answer. 1.19. What is the ratio of the Taxes (in $) in Taxes on income in 1990 to that in 1994?
Offer a terse response. 0.99. What is the ratio of the Taxes (in $) of Taxes on revenue in 1990 to that in 1995?
Your answer should be compact. 0.84. What is the ratio of the Taxes (in $) in Taxes on exports in 1990 to that in 1995?
Make the answer very short. 0.15. What is the ratio of the Taxes (in $) in Taxes on goods and services in 1990 to that in 1995?
Ensure brevity in your answer.  0.79. What is the ratio of the Taxes (in $) of Taxes on income in 1990 to that in 1995?
Offer a terse response. 0.99. What is the ratio of the Taxes (in $) in Taxes on revenue in 1990 to that in 1998?
Provide a succinct answer. 0.51. What is the ratio of the Taxes (in $) of Taxes on exports in 1990 to that in 1998?
Make the answer very short. 0.14. What is the ratio of the Taxes (in $) of Taxes on goods and services in 1990 to that in 1998?
Your answer should be very brief. 0.58. What is the ratio of the Taxes (in $) of Taxes on income in 1990 to that in 1998?
Make the answer very short. 0.55. What is the ratio of the Taxes (in $) of Taxes on revenue in 1991 to that in 1992?
Offer a terse response. 0.95. What is the ratio of the Taxes (in $) of Taxes on exports in 1991 to that in 1992?
Your answer should be compact. 0.9. What is the ratio of the Taxes (in $) in Taxes on goods and services in 1991 to that in 1992?
Ensure brevity in your answer.  1.11. What is the ratio of the Taxes (in $) of Taxes on income in 1991 to that in 1992?
Offer a terse response. 0.97. What is the ratio of the Taxes (in $) of Taxes on exports in 1991 to that in 1993?
Your answer should be compact. 0.84. What is the ratio of the Taxes (in $) in Taxes on goods and services in 1991 to that in 1993?
Your answer should be compact. 1.08. What is the ratio of the Taxes (in $) of Taxes on income in 1991 to that in 1993?
Your answer should be very brief. 0.98. What is the ratio of the Taxes (in $) of Taxes on revenue in 1991 to that in 1994?
Provide a short and direct response. 1.02. What is the ratio of the Taxes (in $) in Taxes on exports in 1991 to that in 1994?
Your response must be concise. 0.28. What is the ratio of the Taxes (in $) in Taxes on goods and services in 1991 to that in 1994?
Offer a terse response. 1.08. What is the ratio of the Taxes (in $) of Taxes on income in 1991 to that in 1994?
Provide a succinct answer. 0.95. What is the ratio of the Taxes (in $) in Taxes on revenue in 1991 to that in 1995?
Give a very brief answer. 0.76. What is the ratio of the Taxes (in $) in Taxes on exports in 1991 to that in 1995?
Offer a very short reply. 0.09. What is the ratio of the Taxes (in $) in Taxes on goods and services in 1991 to that in 1995?
Your answer should be compact. 0.72. What is the ratio of the Taxes (in $) in Taxes on income in 1991 to that in 1995?
Make the answer very short. 0.96. What is the ratio of the Taxes (in $) in Taxes on revenue in 1991 to that in 1998?
Make the answer very short. 0.46. What is the ratio of the Taxes (in $) in Taxes on exports in 1991 to that in 1998?
Give a very brief answer. 0.08. What is the ratio of the Taxes (in $) in Taxes on goods and services in 1991 to that in 1998?
Keep it short and to the point. 0.53. What is the ratio of the Taxes (in $) of Taxes on income in 1991 to that in 1998?
Provide a short and direct response. 0.53. What is the ratio of the Taxes (in $) in Taxes on revenue in 1992 to that in 1993?
Your response must be concise. 1.04. What is the ratio of the Taxes (in $) in Taxes on exports in 1992 to that in 1993?
Offer a very short reply. 0.93. What is the ratio of the Taxes (in $) of Taxes on goods and services in 1992 to that in 1993?
Give a very brief answer. 0.97. What is the ratio of the Taxes (in $) in Taxes on income in 1992 to that in 1993?
Keep it short and to the point. 1.02. What is the ratio of the Taxes (in $) in Taxes on revenue in 1992 to that in 1994?
Your answer should be compact. 1.07. What is the ratio of the Taxes (in $) of Taxes on exports in 1992 to that in 1994?
Your answer should be compact. 0.3. What is the ratio of the Taxes (in $) in Taxes on goods and services in 1992 to that in 1994?
Offer a very short reply. 0.97. What is the ratio of the Taxes (in $) of Taxes on income in 1992 to that in 1994?
Ensure brevity in your answer.  0.98. What is the ratio of the Taxes (in $) of Taxes on exports in 1992 to that in 1995?
Provide a short and direct response. 0.1. What is the ratio of the Taxes (in $) in Taxes on goods and services in 1992 to that in 1995?
Give a very brief answer. 0.64. What is the ratio of the Taxes (in $) of Taxes on income in 1992 to that in 1995?
Make the answer very short. 0.99. What is the ratio of the Taxes (in $) in Taxes on revenue in 1992 to that in 1998?
Your answer should be compact. 0.48. What is the ratio of the Taxes (in $) in Taxes on exports in 1992 to that in 1998?
Your response must be concise. 0.09. What is the ratio of the Taxes (in $) in Taxes on goods and services in 1992 to that in 1998?
Ensure brevity in your answer.  0.47. What is the ratio of the Taxes (in $) of Taxes on income in 1992 to that in 1998?
Your answer should be very brief. 0.55. What is the ratio of the Taxes (in $) in Taxes on revenue in 1993 to that in 1994?
Make the answer very short. 1.03. What is the ratio of the Taxes (in $) of Taxes on exports in 1993 to that in 1994?
Give a very brief answer. 0.33. What is the ratio of the Taxes (in $) of Taxes on income in 1993 to that in 1994?
Ensure brevity in your answer.  0.97. What is the ratio of the Taxes (in $) in Taxes on revenue in 1993 to that in 1995?
Provide a short and direct response. 0.77. What is the ratio of the Taxes (in $) in Taxes on exports in 1993 to that in 1995?
Your answer should be compact. 0.1. What is the ratio of the Taxes (in $) in Taxes on goods and services in 1993 to that in 1995?
Your answer should be compact. 0.66. What is the ratio of the Taxes (in $) of Taxes on income in 1993 to that in 1995?
Your answer should be compact. 0.98. What is the ratio of the Taxes (in $) of Taxes on revenue in 1993 to that in 1998?
Make the answer very short. 0.46. What is the ratio of the Taxes (in $) in Taxes on exports in 1993 to that in 1998?
Make the answer very short. 0.1. What is the ratio of the Taxes (in $) in Taxes on goods and services in 1993 to that in 1998?
Ensure brevity in your answer.  0.48. What is the ratio of the Taxes (in $) in Taxes on income in 1993 to that in 1998?
Provide a short and direct response. 0.54. What is the ratio of the Taxes (in $) in Taxes on revenue in 1994 to that in 1995?
Provide a succinct answer. 0.75. What is the ratio of the Taxes (in $) of Taxes on exports in 1994 to that in 1995?
Keep it short and to the point. 0.31. What is the ratio of the Taxes (in $) of Taxes on goods and services in 1994 to that in 1995?
Provide a short and direct response. 0.66. What is the ratio of the Taxes (in $) of Taxes on income in 1994 to that in 1995?
Your answer should be compact. 1.01. What is the ratio of the Taxes (in $) of Taxes on revenue in 1994 to that in 1998?
Your answer should be compact. 0.45. What is the ratio of the Taxes (in $) of Taxes on exports in 1994 to that in 1998?
Offer a terse response. 0.31. What is the ratio of the Taxes (in $) of Taxes on goods and services in 1994 to that in 1998?
Offer a terse response. 0.49. What is the ratio of the Taxes (in $) in Taxes on income in 1994 to that in 1998?
Your answer should be compact. 0.56. What is the ratio of the Taxes (in $) in Taxes on revenue in 1995 to that in 1998?
Make the answer very short. 0.6. What is the ratio of the Taxes (in $) of Taxes on exports in 1995 to that in 1998?
Offer a very short reply. 0.97. What is the ratio of the Taxes (in $) of Taxes on goods and services in 1995 to that in 1998?
Your answer should be very brief. 0.73. What is the ratio of the Taxes (in $) of Taxes on income in 1995 to that in 1998?
Your answer should be compact. 0.56. What is the difference between the highest and the second highest Taxes (in $) of Taxes on revenue?
Make the answer very short. 2.57e+11. What is the difference between the highest and the second highest Taxes (in $) in Taxes on exports?
Offer a terse response. 1.11e+09. What is the difference between the highest and the second highest Taxes (in $) in Taxes on goods and services?
Your answer should be compact. 4.89e+1. What is the difference between the highest and the second highest Taxes (in $) in Taxes on income?
Your response must be concise. 7.18e+1. What is the difference between the highest and the lowest Taxes (in $) of Taxes on revenue?
Keep it short and to the point. 3.55e+11. What is the difference between the highest and the lowest Taxes (in $) in Taxes on exports?
Offer a very short reply. 3.97e+1. What is the difference between the highest and the lowest Taxes (in $) in Taxes on goods and services?
Provide a short and direct response. 9.69e+1. What is the difference between the highest and the lowest Taxes (in $) of Taxes on income?
Provide a succinct answer. 7.63e+1. 